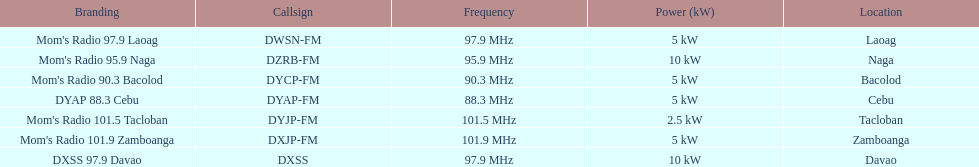Parse the table in full. {'header': ['Branding', 'Callsign', 'Frequency', 'Power (kW)', 'Location'], 'rows': [["Mom's Radio 97.9 Laoag", 'DWSN-FM', '97.9\xa0MHz', '5\xa0kW', 'Laoag'], ["Mom's Radio 95.9 Naga", 'DZRB-FM', '95.9\xa0MHz', '10\xa0kW', 'Naga'], ["Mom's Radio 90.3 Bacolod", 'DYCP-FM', '90.3\xa0MHz', '5\xa0kW', 'Bacolod'], ['DYAP 88.3 Cebu', 'DYAP-FM', '88.3\xa0MHz', '5\xa0kW', 'Cebu'], ["Mom's Radio 101.5 Tacloban", 'DYJP-FM', '101.5\xa0MHz', '2.5\xa0kW', 'Tacloban'], ["Mom's Radio 101.9 Zamboanga", 'DXJP-FM', '101.9\xa0MHz', '5\xa0kW', 'Zamboanga'], ['DXSS 97.9 Davao', 'DXSS', '97.9\xa0MHz', '10\xa0kW', 'Davao']]} What is the last location on this chart? Davao. 